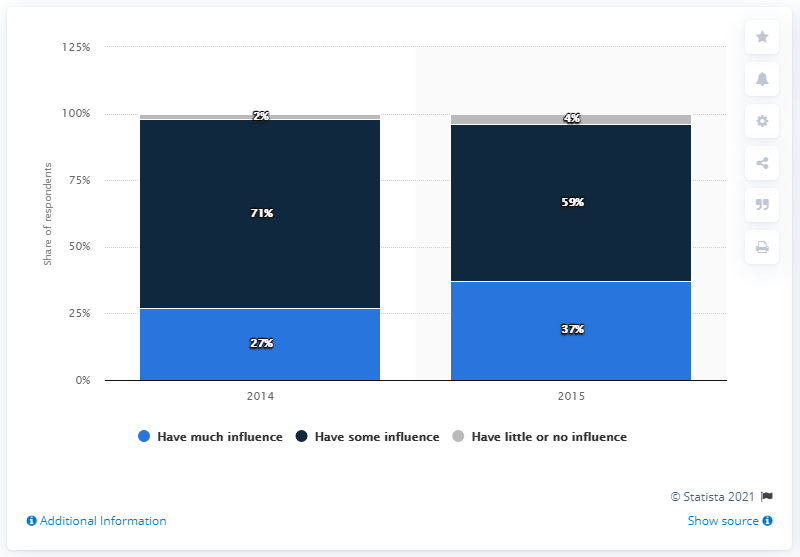Indicate a few pertinent items in this graphic. Gray is the color that has the least percentage. The average value of the phrase "have some influence" when it is followed by a number is approximately 65. 